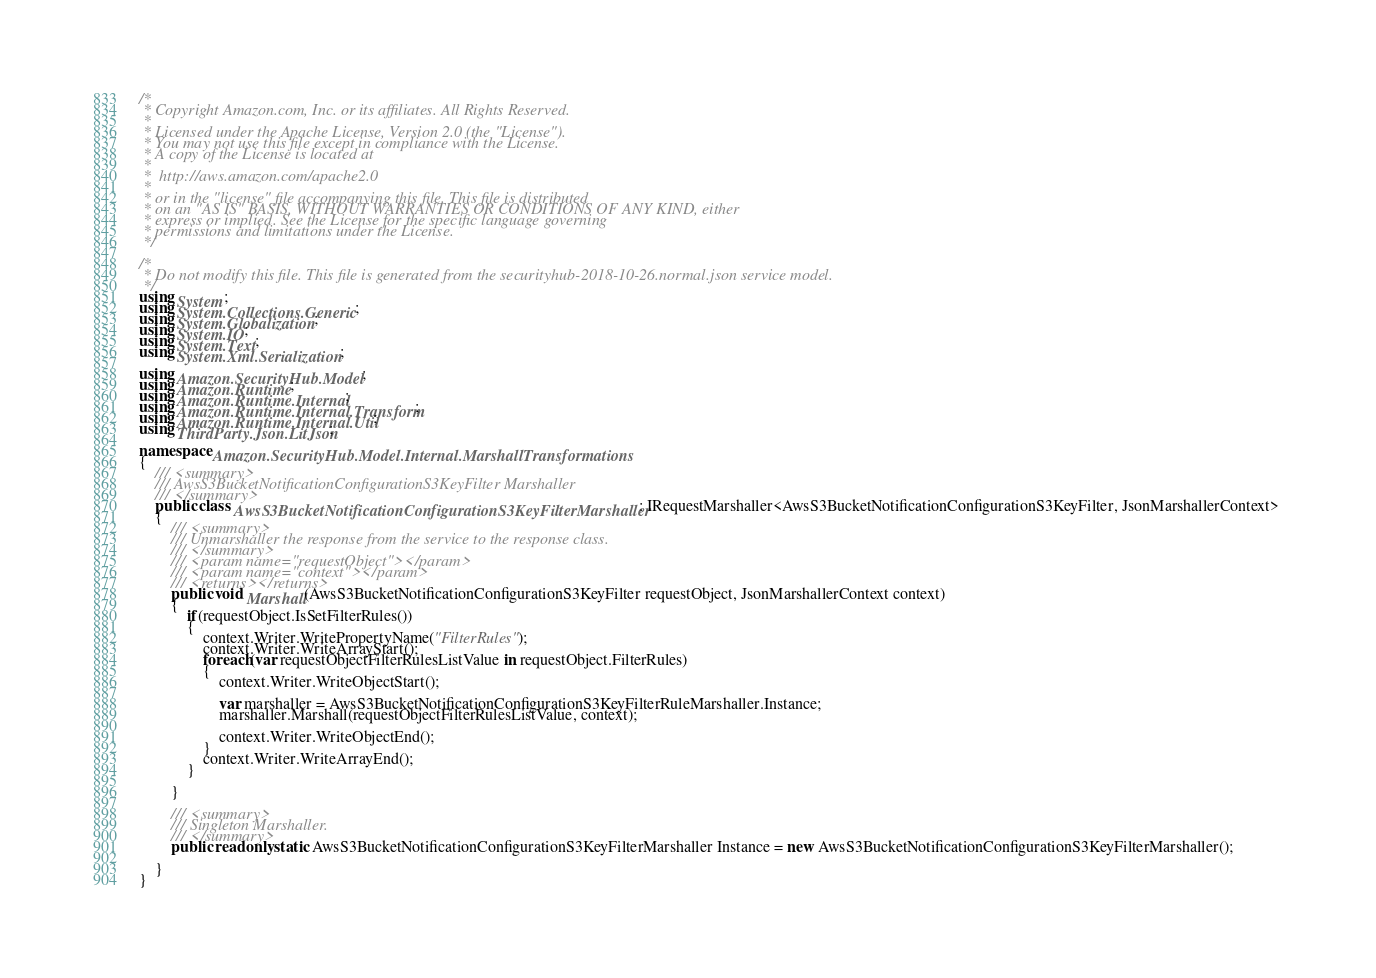<code> <loc_0><loc_0><loc_500><loc_500><_C#_>/*
 * Copyright Amazon.com, Inc. or its affiliates. All Rights Reserved.
 * 
 * Licensed under the Apache License, Version 2.0 (the "License").
 * You may not use this file except in compliance with the License.
 * A copy of the License is located at
 * 
 *  http://aws.amazon.com/apache2.0
 * 
 * or in the "license" file accompanying this file. This file is distributed
 * on an "AS IS" BASIS, WITHOUT WARRANTIES OR CONDITIONS OF ANY KIND, either
 * express or implied. See the License for the specific language governing
 * permissions and limitations under the License.
 */

/*
 * Do not modify this file. This file is generated from the securityhub-2018-10-26.normal.json service model.
 */
using System;
using System.Collections.Generic;
using System.Globalization;
using System.IO;
using System.Text;
using System.Xml.Serialization;

using Amazon.SecurityHub.Model;
using Amazon.Runtime;
using Amazon.Runtime.Internal;
using Amazon.Runtime.Internal.Transform;
using Amazon.Runtime.Internal.Util;
using ThirdParty.Json.LitJson;

namespace Amazon.SecurityHub.Model.Internal.MarshallTransformations
{
    /// <summary>
    /// AwsS3BucketNotificationConfigurationS3KeyFilter Marshaller
    /// </summary>
    public class AwsS3BucketNotificationConfigurationS3KeyFilterMarshaller : IRequestMarshaller<AwsS3BucketNotificationConfigurationS3KeyFilter, JsonMarshallerContext> 
    {
        /// <summary>
        /// Unmarshaller the response from the service to the response class.
        /// </summary>  
        /// <param name="requestObject"></param>
        /// <param name="context"></param>
        /// <returns></returns>
        public void Marshall(AwsS3BucketNotificationConfigurationS3KeyFilter requestObject, JsonMarshallerContext context)
        {
            if(requestObject.IsSetFilterRules())
            {
                context.Writer.WritePropertyName("FilterRules");
                context.Writer.WriteArrayStart();
                foreach(var requestObjectFilterRulesListValue in requestObject.FilterRules)
                {
                    context.Writer.WriteObjectStart();

                    var marshaller = AwsS3BucketNotificationConfigurationS3KeyFilterRuleMarshaller.Instance;
                    marshaller.Marshall(requestObjectFilterRulesListValue, context);

                    context.Writer.WriteObjectEnd();
                }
                context.Writer.WriteArrayEnd();
            }

        }

        /// <summary>
        /// Singleton Marshaller.
        /// </summary>
        public readonly static AwsS3BucketNotificationConfigurationS3KeyFilterMarshaller Instance = new AwsS3BucketNotificationConfigurationS3KeyFilterMarshaller();

    }
}</code> 